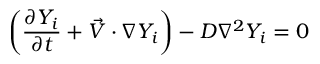<formula> <loc_0><loc_0><loc_500><loc_500>\left ( \frac { \partial Y _ { i } } { \partial t } + \vec { V } \cdot \nabla Y _ { i } \right ) - D \nabla ^ { 2 } Y _ { i } = 0</formula> 